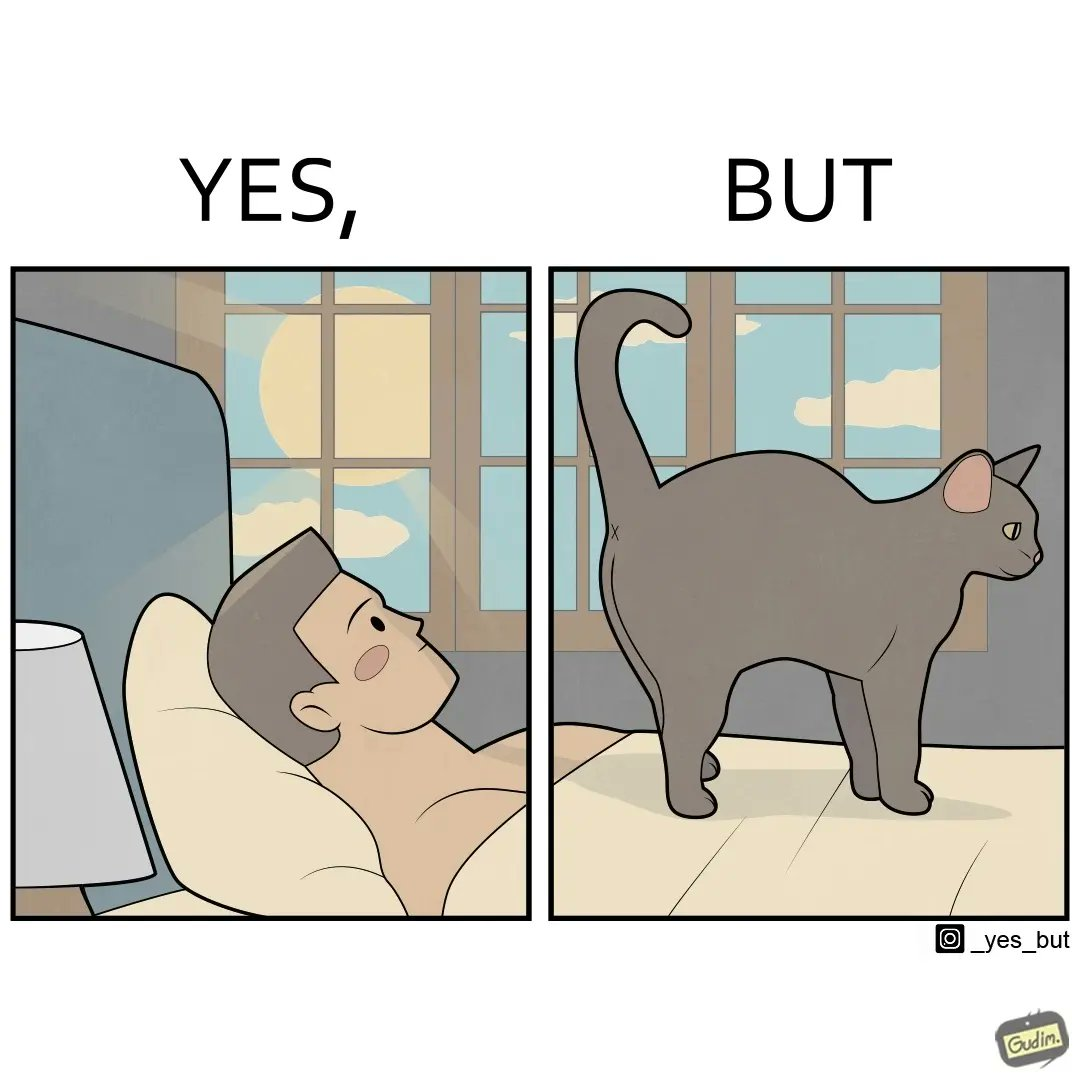Provide a description of this image. The image just speaks yes, but in a different way as "yes, butt" like in the early morning the man had to look at the cat's butt because it is standing over the man's body 